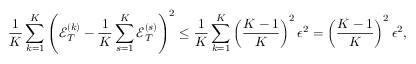<formula> <loc_0><loc_0><loc_500><loc_500>\frac { 1 } { K } \sum _ { k = 1 } ^ { K } \left ( { \mathcal { E } } _ { T } ^ { ( k ) } - \frac { 1 } { K } \sum _ { s = 1 } ^ { K } { \mathcal { E } } _ { T } ^ { ( s ) } \right ) ^ { 2 } \leq \frac { 1 } { K } \sum _ { k = 1 } ^ { K } \left ( \frac { K - 1 } { K } \right ) ^ { 2 } \epsilon ^ { 2 } = \left ( \frac { K - 1 } { K } \right ) ^ { 2 } \epsilon ^ { 2 } ,</formula> 